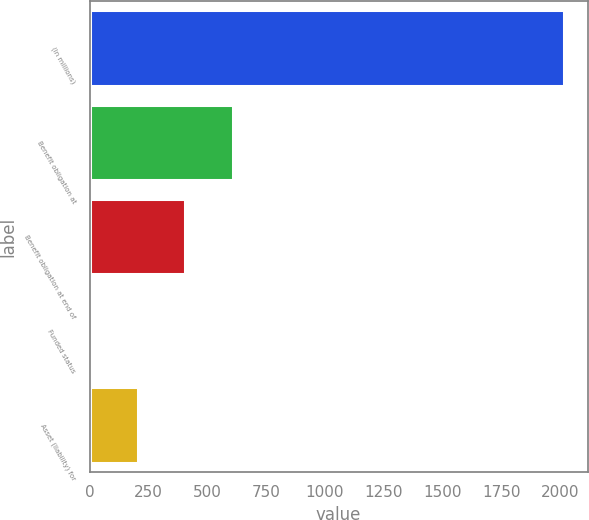Convert chart. <chart><loc_0><loc_0><loc_500><loc_500><bar_chart><fcel>(In millions)<fcel>Benefit obligation at<fcel>Benefit obligation at end of<fcel>Funded status<fcel>Asset (liability) for<nl><fcel>2016<fcel>607.6<fcel>406.4<fcel>4<fcel>205.2<nl></chart> 